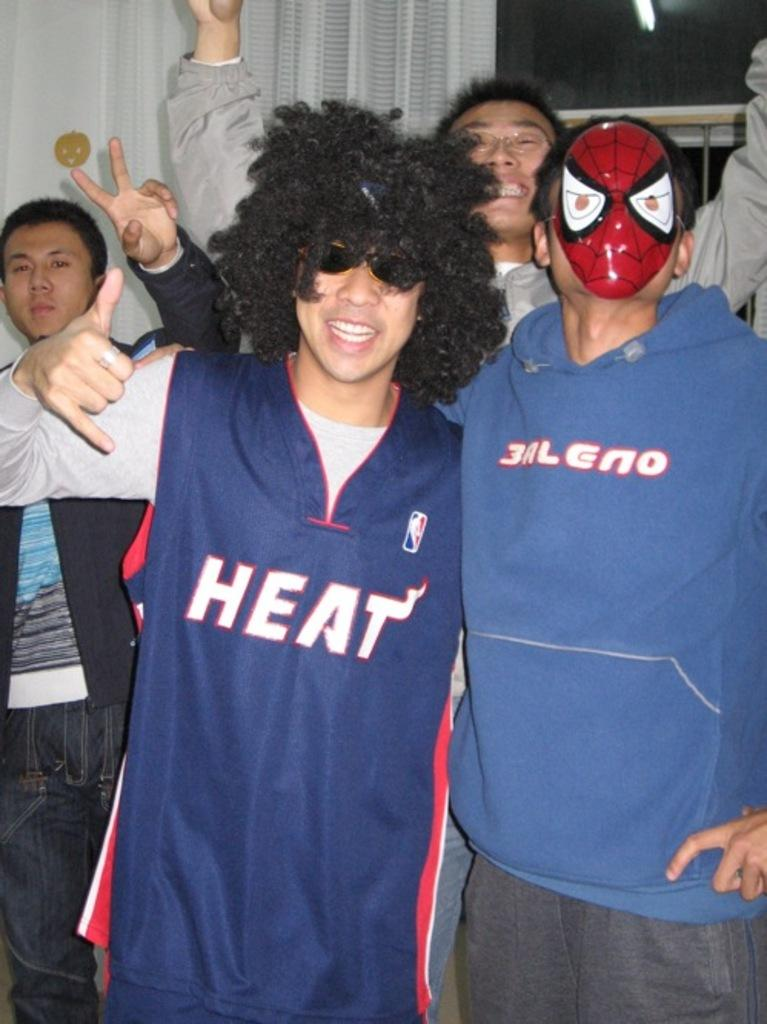<image>
Describe the image concisely. a person with a Heat jersey on posing 